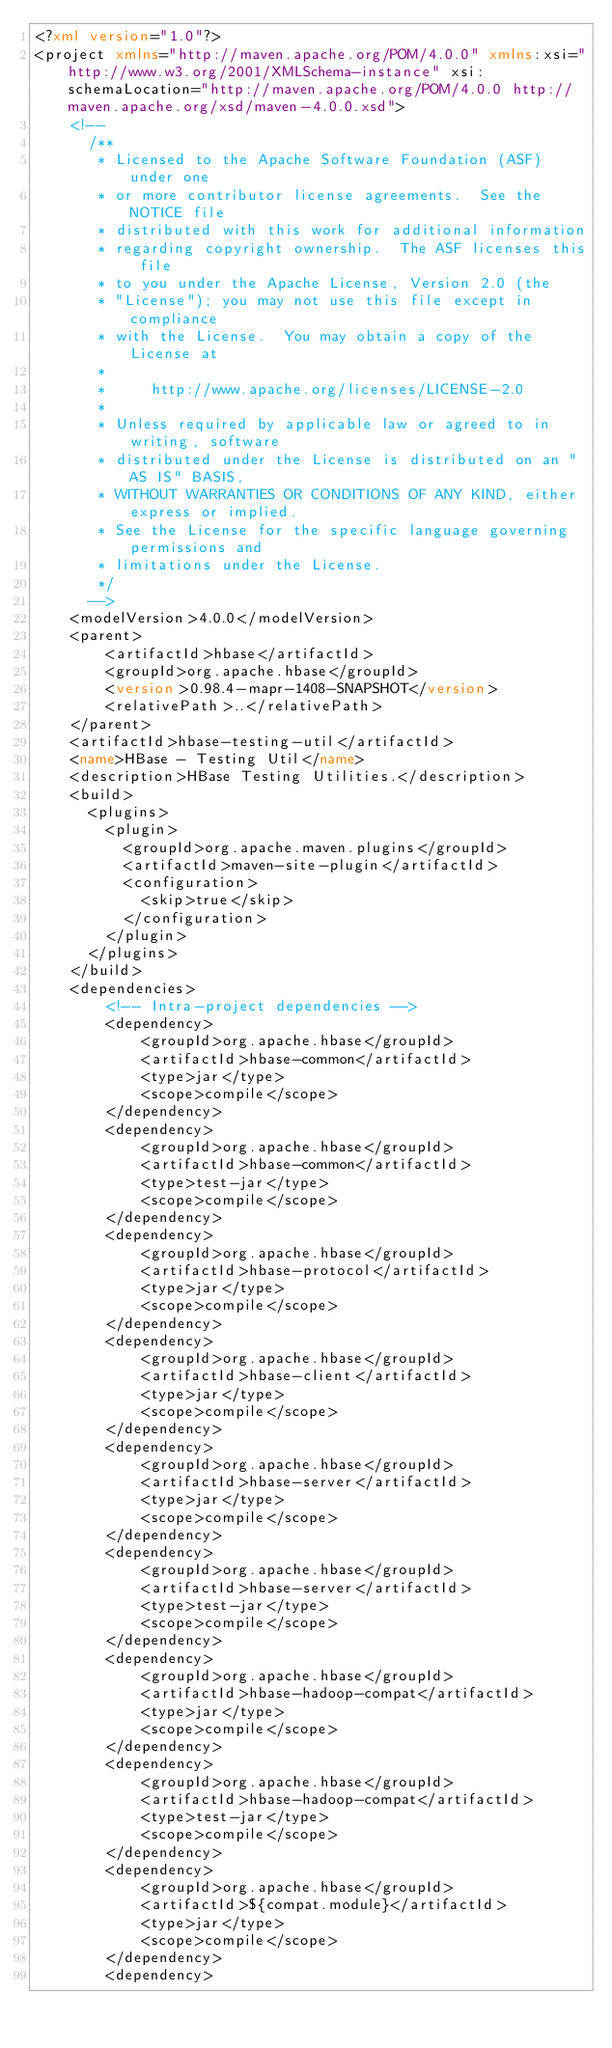<code> <loc_0><loc_0><loc_500><loc_500><_XML_><?xml version="1.0"?>
<project xmlns="http://maven.apache.org/POM/4.0.0" xmlns:xsi="http://www.w3.org/2001/XMLSchema-instance" xsi:schemaLocation="http://maven.apache.org/POM/4.0.0 http://maven.apache.org/xsd/maven-4.0.0.xsd">
    <!--
      /**
       * Licensed to the Apache Software Foundation (ASF) under one
       * or more contributor license agreements.  See the NOTICE file
       * distributed with this work for additional information
       * regarding copyright ownership.  The ASF licenses this file
       * to you under the Apache License, Version 2.0 (the
       * "License"); you may not use this file except in compliance
       * with the License.  You may obtain a copy of the License at
       *
       *     http://www.apache.org/licenses/LICENSE-2.0
       *
       * Unless required by applicable law or agreed to in writing, software
       * distributed under the License is distributed on an "AS IS" BASIS,
       * WITHOUT WARRANTIES OR CONDITIONS OF ANY KIND, either express or implied.
       * See the License for the specific language governing permissions and
       * limitations under the License.
       */
      -->
    <modelVersion>4.0.0</modelVersion>
    <parent>
        <artifactId>hbase</artifactId>
        <groupId>org.apache.hbase</groupId>
        <version>0.98.4-mapr-1408-SNAPSHOT</version>
        <relativePath>..</relativePath>
    </parent>
    <artifactId>hbase-testing-util</artifactId>
    <name>HBase - Testing Util</name>
    <description>HBase Testing Utilities.</description>
    <build>
      <plugins>
        <plugin>
          <groupId>org.apache.maven.plugins</groupId>
          <artifactId>maven-site-plugin</artifactId>
          <configuration>
            <skip>true</skip>
          </configuration>
        </plugin>
      </plugins>
    </build>
    <dependencies>
        <!-- Intra-project dependencies -->
        <dependency>
            <groupId>org.apache.hbase</groupId>
            <artifactId>hbase-common</artifactId>
            <type>jar</type>
            <scope>compile</scope>
        </dependency>
        <dependency>
            <groupId>org.apache.hbase</groupId>
            <artifactId>hbase-common</artifactId>
            <type>test-jar</type>
            <scope>compile</scope>
        </dependency>
        <dependency>
            <groupId>org.apache.hbase</groupId>
            <artifactId>hbase-protocol</artifactId>
            <type>jar</type>
            <scope>compile</scope>
        </dependency>
        <dependency>
            <groupId>org.apache.hbase</groupId>
            <artifactId>hbase-client</artifactId>
            <type>jar</type>
            <scope>compile</scope>
        </dependency>
        <dependency>
            <groupId>org.apache.hbase</groupId>
            <artifactId>hbase-server</artifactId>
            <type>jar</type>
            <scope>compile</scope>
        </dependency>
        <dependency>
            <groupId>org.apache.hbase</groupId>
            <artifactId>hbase-server</artifactId>
            <type>test-jar</type>
            <scope>compile</scope>
        </dependency>
        <dependency>
            <groupId>org.apache.hbase</groupId>
            <artifactId>hbase-hadoop-compat</artifactId>
            <type>jar</type>
            <scope>compile</scope>
        </dependency>
        <dependency>
            <groupId>org.apache.hbase</groupId>
            <artifactId>hbase-hadoop-compat</artifactId>
            <type>test-jar</type>
            <scope>compile</scope>
        </dependency>
        <dependency>
            <groupId>org.apache.hbase</groupId>
            <artifactId>${compat.module}</artifactId>
            <type>jar</type>
            <scope>compile</scope>
        </dependency>
        <dependency></code> 